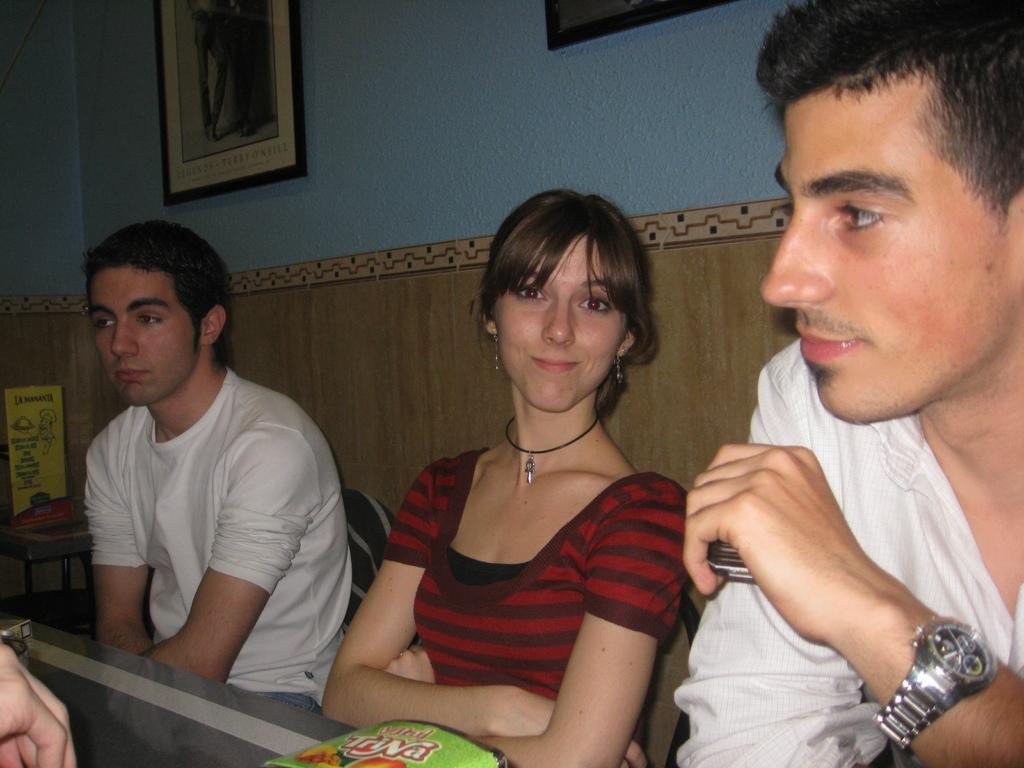In one or two sentences, can you explain what this image depicts? In this image, we can see people sitting and there are some objects on the table. In the background, there are frames on the wall and we can see a box placed on the stand. 